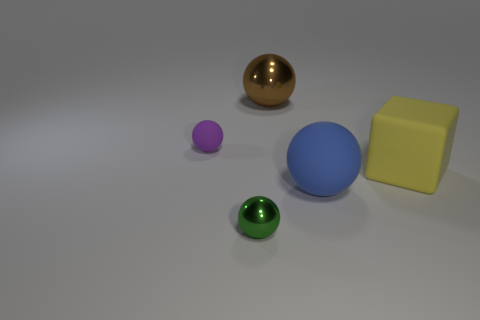Subtract all large brown shiny balls. How many balls are left? 3 Subtract 1 balls. How many balls are left? 3 Add 1 large rubber blocks. How many objects exist? 6 Subtract all blocks. How many objects are left? 4 Subtract all brown balls. How many balls are left? 3 Subtract 0 brown cylinders. How many objects are left? 5 Subtract all red cubes. Subtract all yellow cylinders. How many cubes are left? 1 Subtract all large cubes. Subtract all metal objects. How many objects are left? 2 Add 4 green shiny objects. How many green shiny objects are left? 5 Add 1 small green metallic things. How many small green metallic things exist? 2 